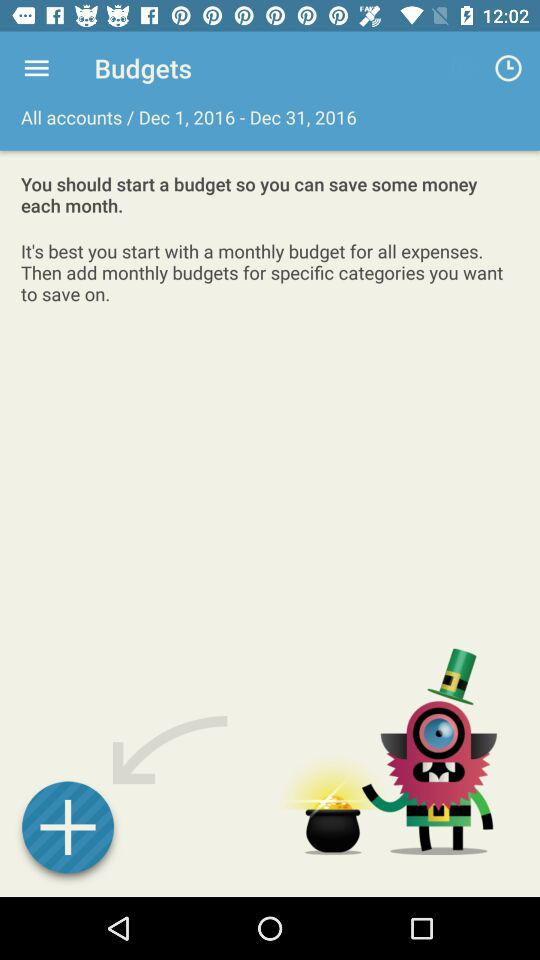What is the selected date range? The selected date range is Dec 1, 2016-Dec 31, 2016. 